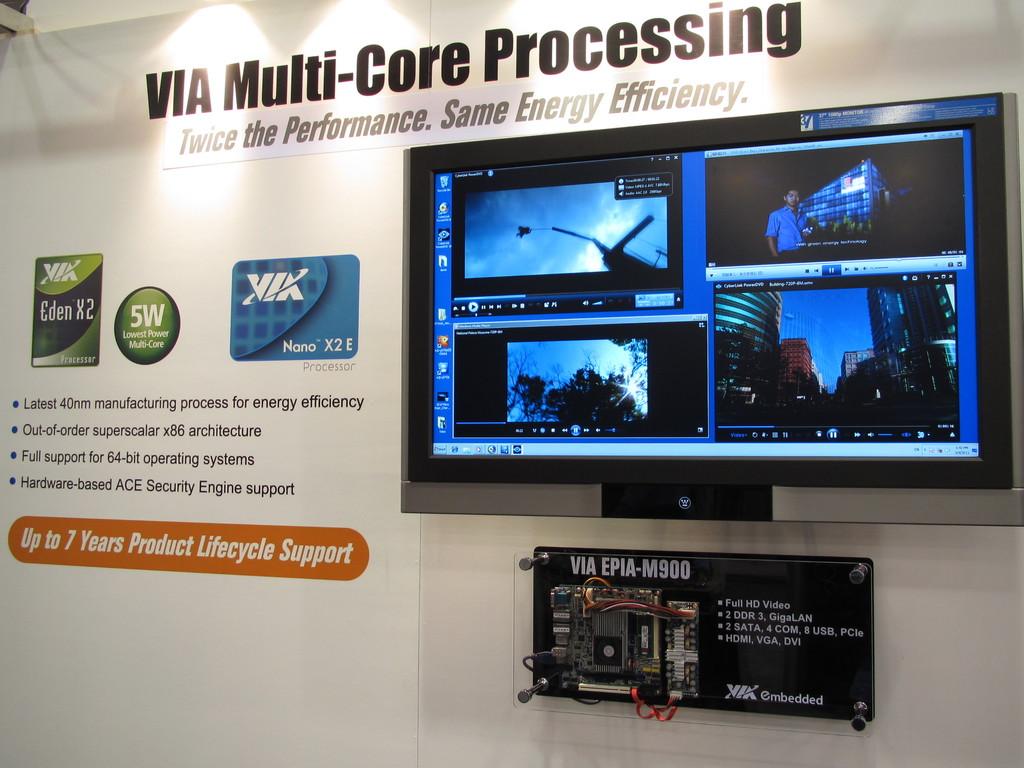What kind of processing is this?
Provide a short and direct response. Multi-core. What is the brand of processor on the ad?
Offer a terse response. Via. 